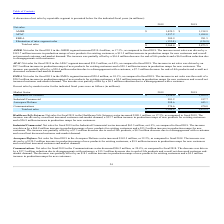From Plexus's financial document, Which years does the table provide information for the company's net sales by market sector? The document shows two values: 2019 and 2018. From the document: "Market Sector 2019 2018 Market Sector 2019 2018..." Also, What was the net sales in the healthcare/life sciences sector in 2019? According to the financial document, 1,220.0 (in millions). The relevant text states: "Healthcare/Life Sciences $ 1,220.0 $ 1,039.9..." Also, What was the net sales in the aerospace/defense sector in 2018? According to the financial document, 445.1 (in millions). The relevant text states: "Aerospace/Defense 588.6 445.1..." Additionally, Which years did the net sales from Communications exceed $400 million? According to the financial document, 2018. The relevant text states: "Market Sector 2019 2018..." Also, can you calculate: What was the difference in the net sales in 2019 between the industrial/commercial and communications sector? Based on the calculation: 981.2-374.6, the result is 606.6 (in millions). This is based on the information: "Industrial/Commercial 981.2 917.7 Communications 374.6 470.8..." The key data points involved are: 374.6, 981.2. Also, can you calculate: What was the percentage change in the total net sales between 2018 and 2019? To answer this question, I need to perform calculations using the financial data. The calculation is: (3,164.4-2,873.5)/2,873.5, which equals 10.12 (percentage). This is based on the information: "Total net sales $ 3,164.4 $ 2,873.5 Total net sales $ 3,164.4 $ 2,873.5..." The key data points involved are: 2,873.5, 3,164.4. 